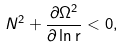Convert formula to latex. <formula><loc_0><loc_0><loc_500><loc_500>N ^ { 2 } + \frac { \partial \Omega ^ { 2 } } { \partial \ln \mathrm r } < 0 ,</formula> 